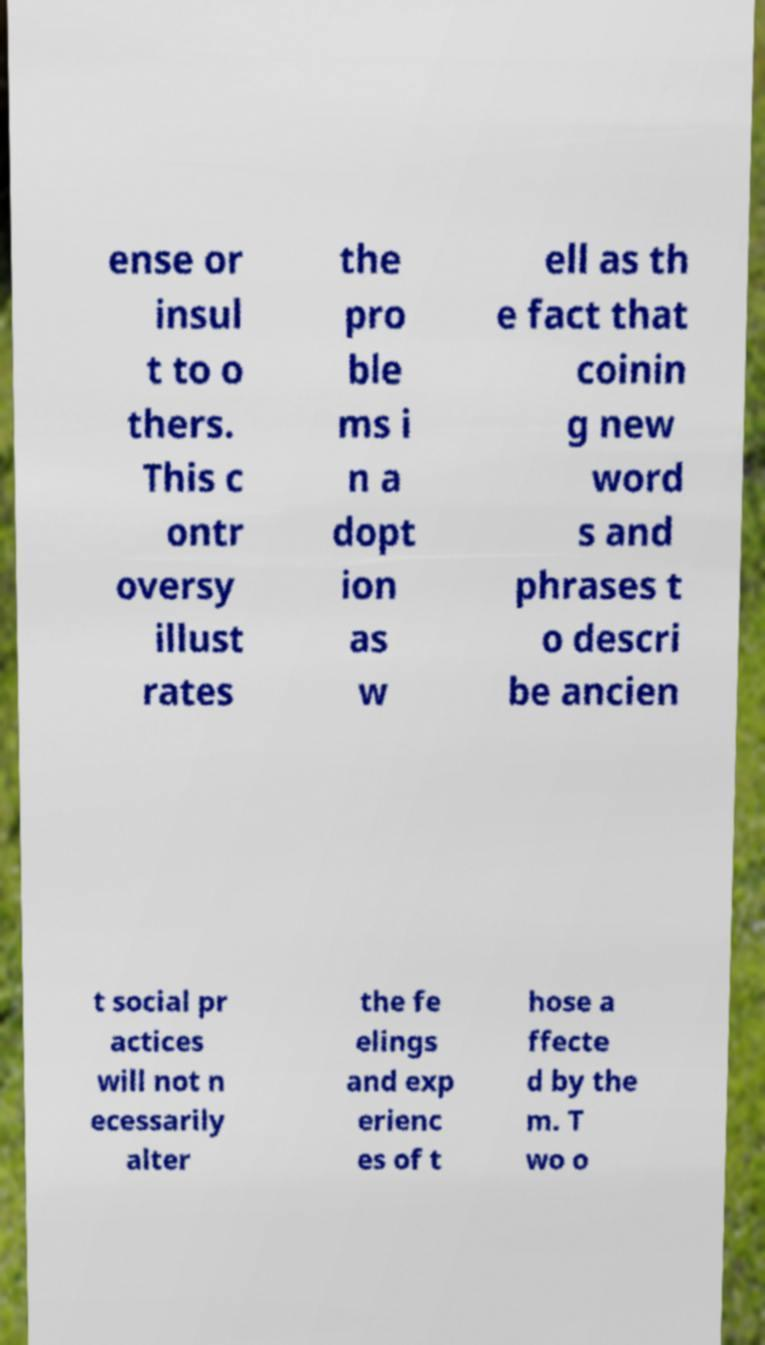For documentation purposes, I need the text within this image transcribed. Could you provide that? ense or insul t to o thers. This c ontr oversy illust rates the pro ble ms i n a dopt ion as w ell as th e fact that coinin g new word s and phrases t o descri be ancien t social pr actices will not n ecessarily alter the fe elings and exp erienc es of t hose a ffecte d by the m. T wo o 